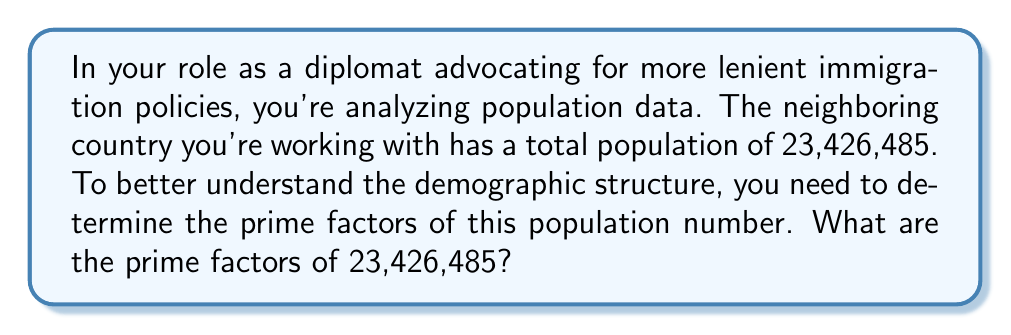Can you solve this math problem? To find the prime factors of 23,426,485, we'll use the process of prime factorization:

1) First, let's try dividing by the smallest prime number, 2:
   23,426,485 ÷ 2 = 11,713,242.5 (not divisible)

2) Next, we'll try 3:
   23,426,485 ÷ 3 = 7,808,828.33... (not divisible)

3) Let's try 5:
   23,426,485 ÷ 5 = 4,685,297 (divisible)

4) Now we have: 23,426,485 = 5 × 4,685,297

5) Let's continue factoring 4,685,297:
   4,685,297 ÷ 5 = 937,059.4 (not divisible)
   4,685,297 ÷ 7 = 669,328.14... (not divisible)

6) After trying several more primes, we find:
   4,685,297 ÷ 11 = 425,936.09... (not divisible)
   4,685,297 ÷ 13 = 360,407.46... (not divisible)
   4,685,297 ÷ 17 = 275,605.70... (not divisible)
   4,685,297 ÷ 19 = 246,594.57... (not divisible)
   4,685,297 ÷ 23 = 203,708.56... (not divisible)

7) Finally, we find:
   4,685,297 ÷ 29 = 161,561.27... (not divisible)
   4,685,297 ÷ 31 = 151,138.61... (divisible)

8) Now we have: 4,685,297 = 31 × 151,138

9) Continuing to factor 151,138:
   151,138 ÷ 2 = 75,569 (divisible)
   75,569 is prime

Therefore, the complete prime factorization is:

$$23,426,485 = 5 \times 31 \times 2 \times 75,569$$
Answer: $5, 31, 2, 75569$ 